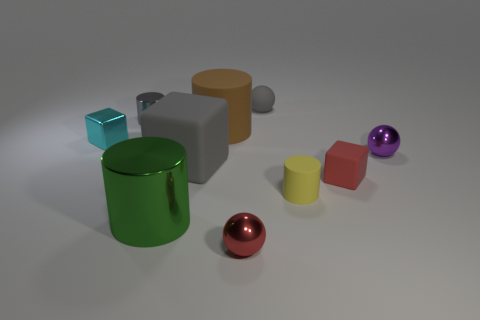Subtract all cylinders. How many objects are left? 6 Add 3 large blue rubber balls. How many large blue rubber balls exist? 3 Subtract 0 blue cubes. How many objects are left? 10 Subtract all red shiny balls. Subtract all big purple objects. How many objects are left? 9 Add 4 big cylinders. How many big cylinders are left? 6 